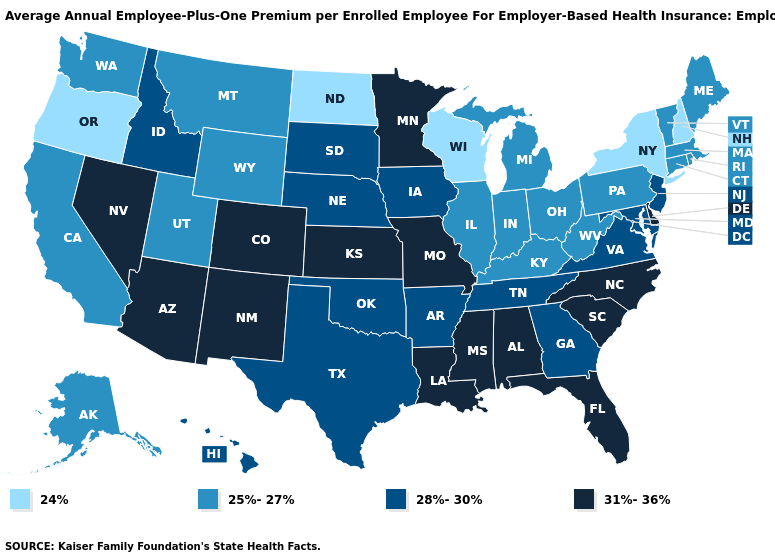Name the states that have a value in the range 31%-36%?
Be succinct. Alabama, Arizona, Colorado, Delaware, Florida, Kansas, Louisiana, Minnesota, Mississippi, Missouri, Nevada, New Mexico, North Carolina, South Carolina. Which states hav the highest value in the Northeast?
Concise answer only. New Jersey. Does the first symbol in the legend represent the smallest category?
Write a very short answer. Yes. Among the states that border Florida , does Georgia have the lowest value?
Concise answer only. Yes. Does Wisconsin have the lowest value in the USA?
Short answer required. Yes. Name the states that have a value in the range 28%-30%?
Concise answer only. Arkansas, Georgia, Hawaii, Idaho, Iowa, Maryland, Nebraska, New Jersey, Oklahoma, South Dakota, Tennessee, Texas, Virginia. Does Nebraska have the same value as Virginia?
Keep it brief. Yes. What is the value of Ohio?
Quick response, please. 25%-27%. What is the value of Montana?
Write a very short answer. 25%-27%. What is the value of Massachusetts?
Concise answer only. 25%-27%. Does Massachusetts have the same value as Georgia?
Keep it brief. No. Does New Jersey have the highest value in the Northeast?
Short answer required. Yes. Name the states that have a value in the range 25%-27%?
Concise answer only. Alaska, California, Connecticut, Illinois, Indiana, Kentucky, Maine, Massachusetts, Michigan, Montana, Ohio, Pennsylvania, Rhode Island, Utah, Vermont, Washington, West Virginia, Wyoming. Which states hav the highest value in the South?
Be succinct. Alabama, Delaware, Florida, Louisiana, Mississippi, North Carolina, South Carolina. 